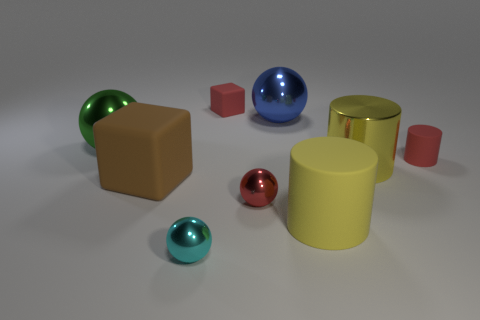Subtract 1 balls. How many balls are left? 3 Add 1 tiny gray cubes. How many objects exist? 10 Subtract all balls. How many objects are left? 5 Subtract 1 red blocks. How many objects are left? 8 Subtract all small red rubber objects. Subtract all red objects. How many objects are left? 4 Add 2 brown matte blocks. How many brown matte blocks are left? 3 Add 1 large brown blocks. How many large brown blocks exist? 2 